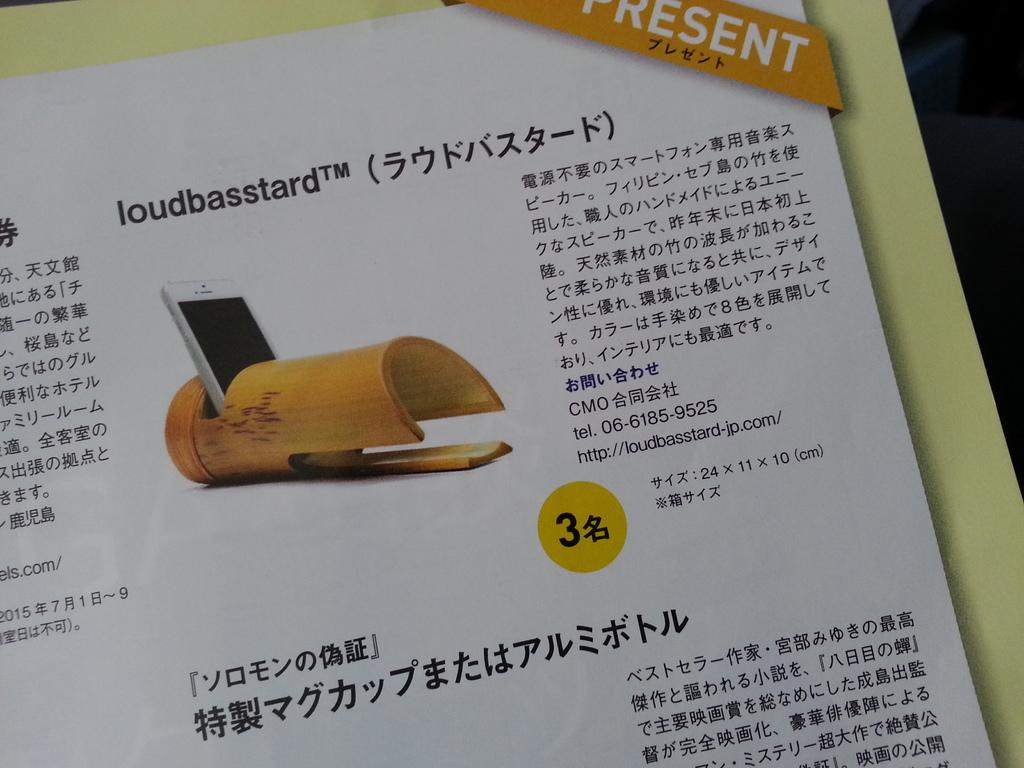<image>
Give a short and clear explanation of the subsequent image. A Chinese poster with a  picture of a white phone  with the word present on top. 